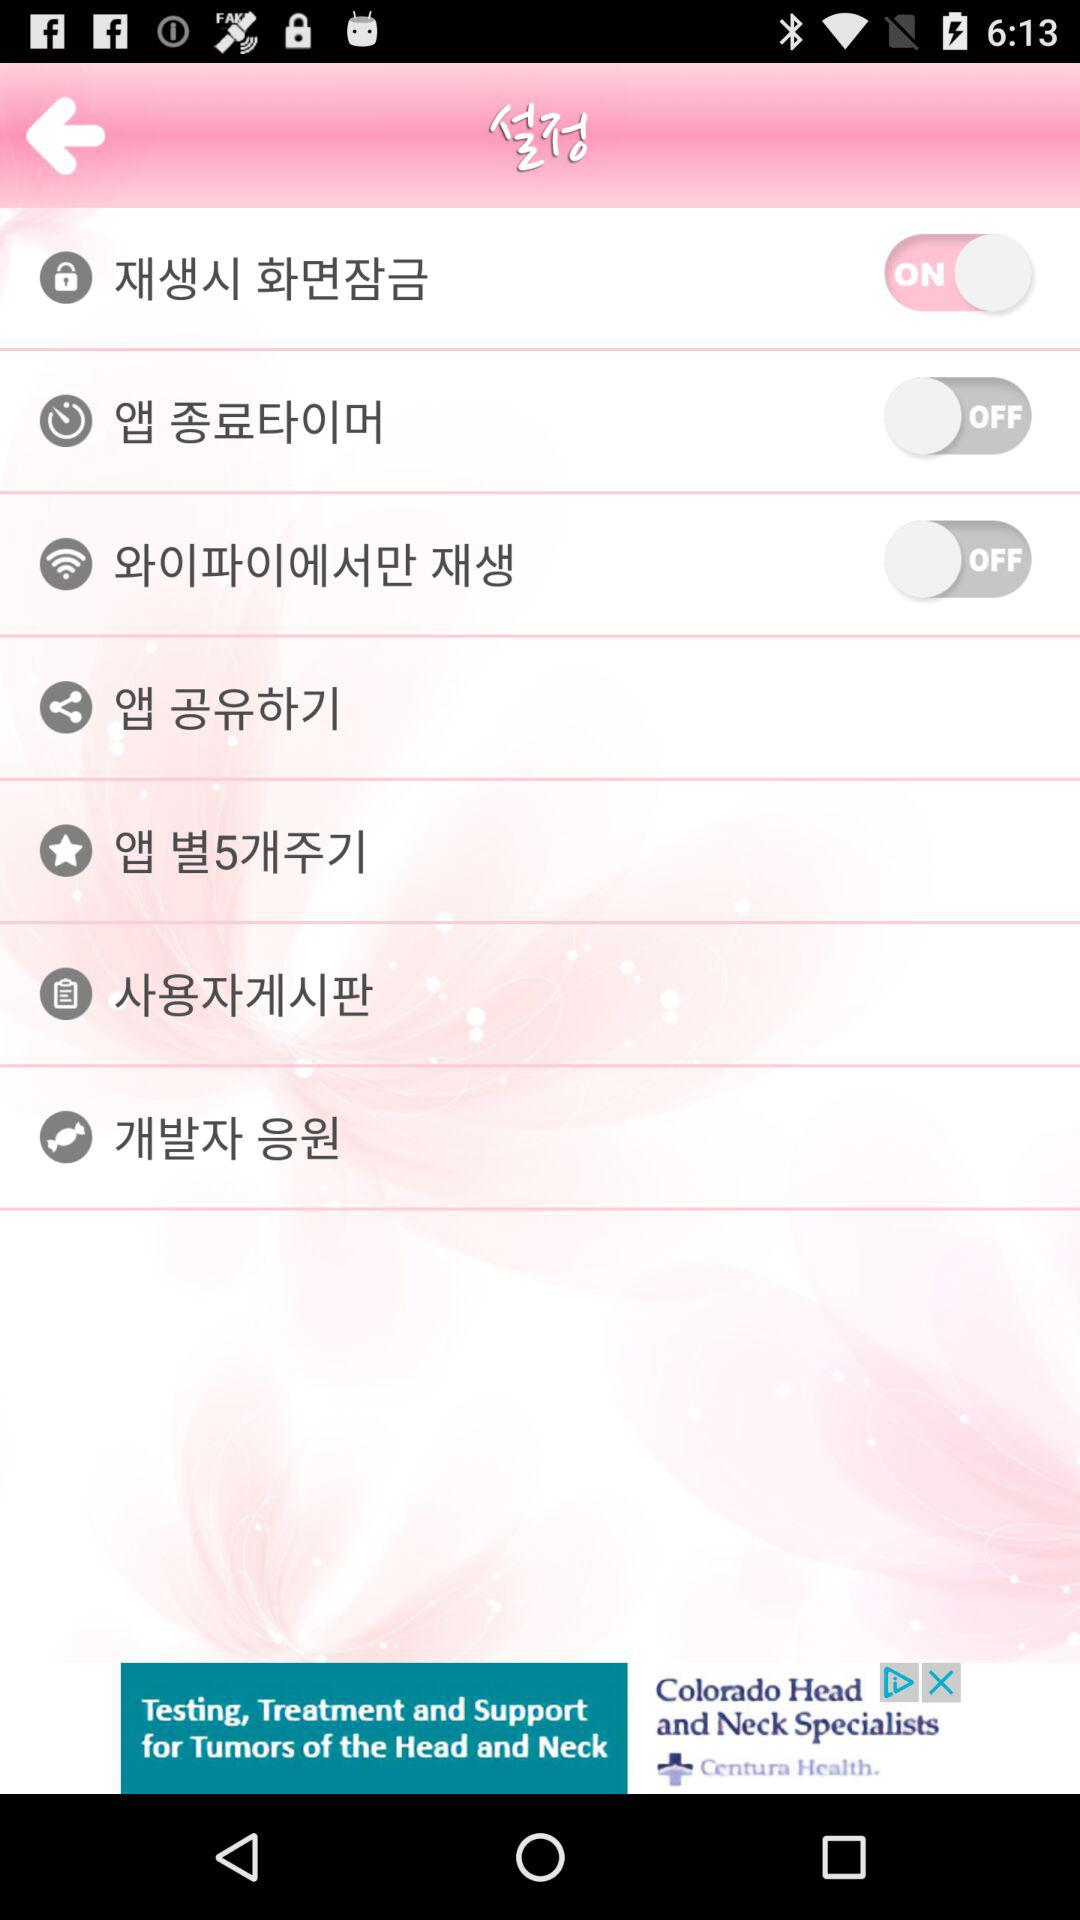How many switches are there in the settings menu?
Answer the question using a single word or phrase. 3 